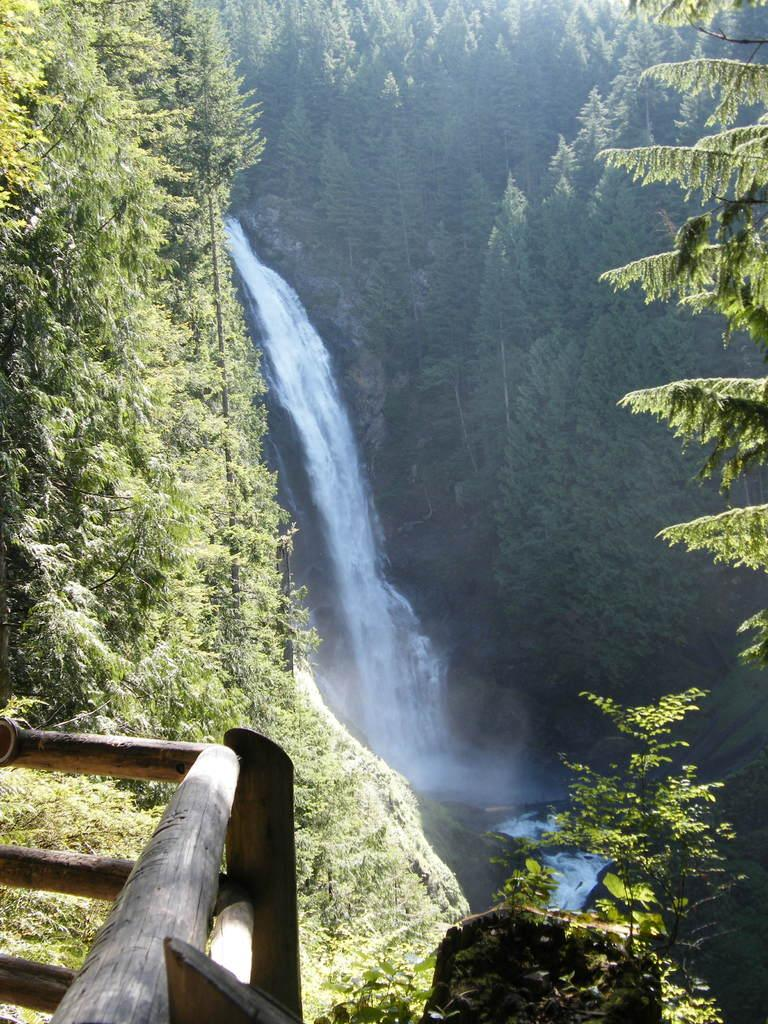What natural feature is the main subject of the image? There is a waterfall in the image. What type of vegetation can be seen in the image? There are trees in the image. Where is the fencing with woods located in the image? The fencing with woods is in the left bottom corner of the image. How many cabbages are growing near the waterfall in the image? There are no cabbages present in the image. What type of dogs can be seen playing near the trees in the image? There are no dogs present in the image. 